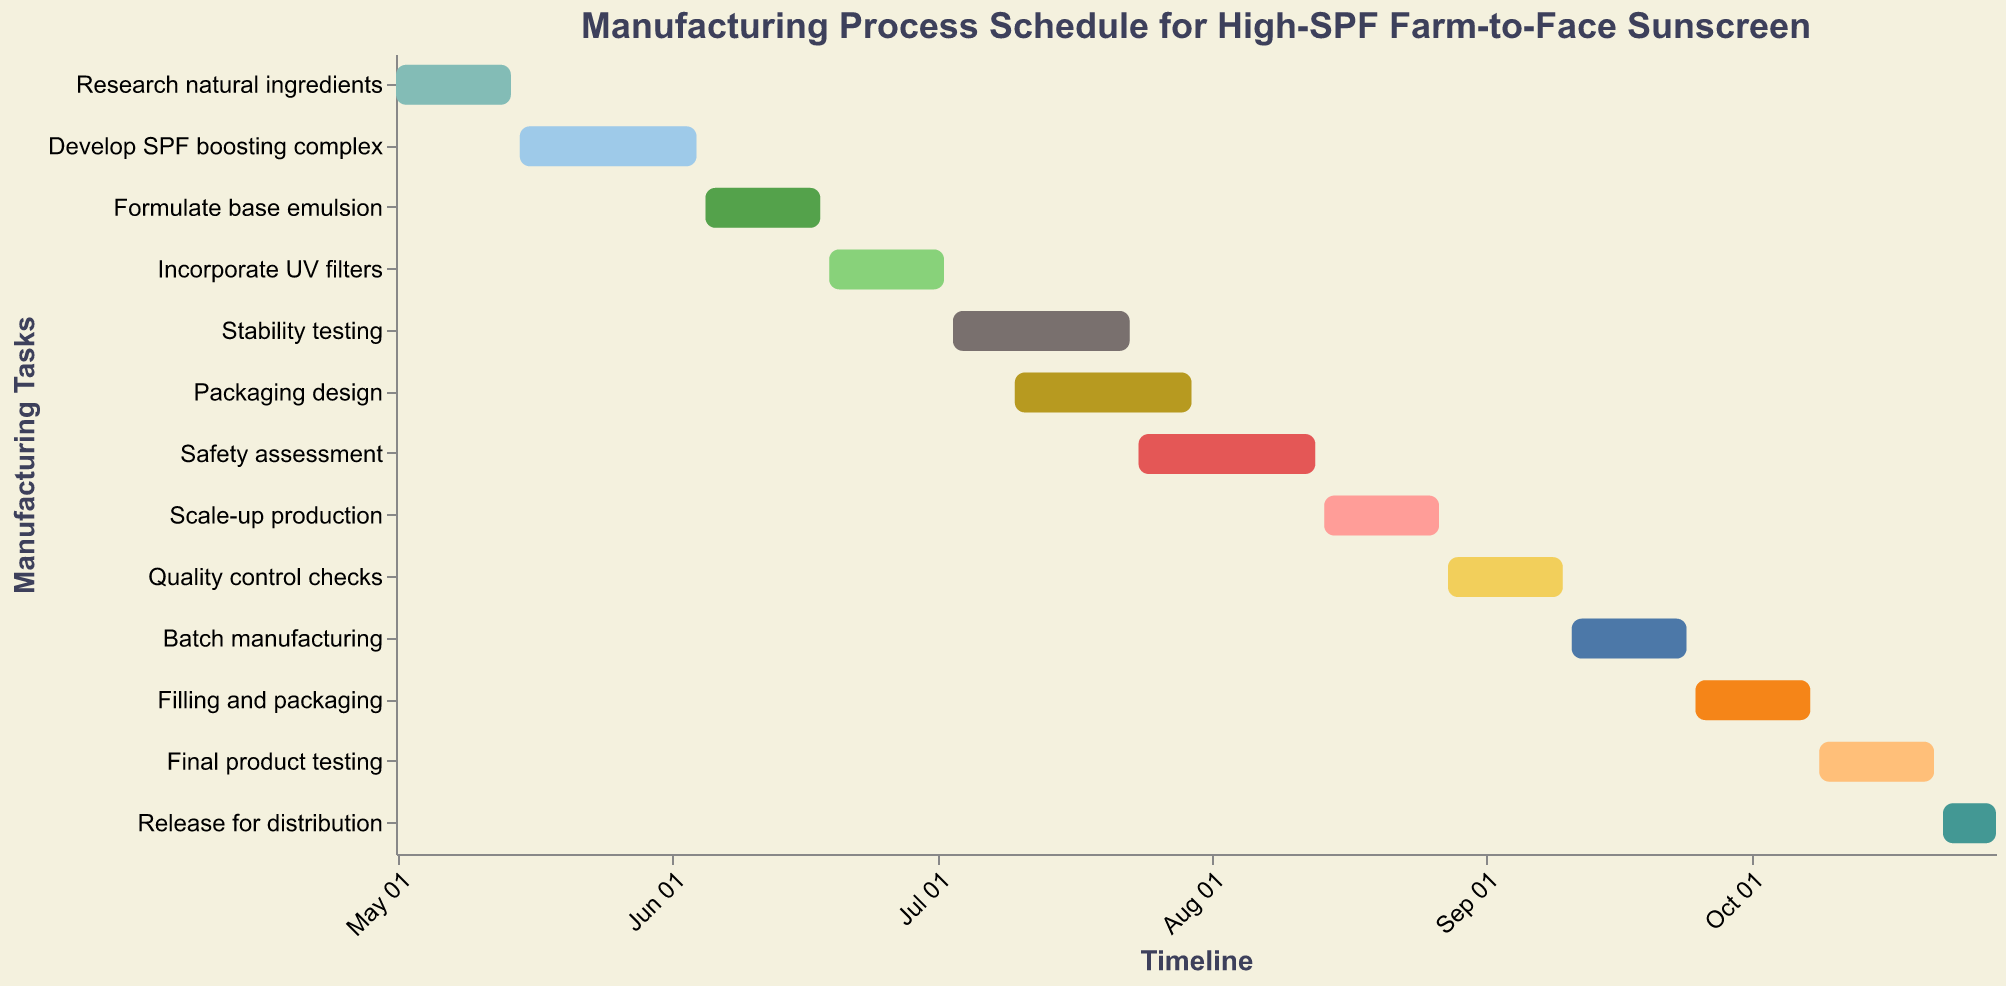What is the title of the figure? The title is located at the top of the Gantt Chart. It is "Manufacturing Process Schedule for High-SPF Farm-to-Face Sunscreen".
Answer: Manufacturing Process Schedule for High-SPF Farm-to-Face Sunscreen How many tasks are shown in the chart? Count the number of bars/tasks listed along the y-axis. There are 13 tasks in total.
Answer: 13 Which task starts first and on what date? The task that starts first can be identified by looking for the bar that begins at the earliest date on the x-axis. "Research natural ingredients" starts on May 1, 2023.
Answer: Research natural ingredients, May 1, 2023 When does the "Scale-up production" task begin and end? Locate the "Scale-up production" task along the y-axis and refer to the corresponding start and end dates along the x-axis. It starts on August 14, 2023, and ends on August 27, 2023.
Answer: August 14, 2023, to August 27, 2023 Which tasks are overlapping with "Stability testing"? Find "Stability testing" on the y-axis and note its duration. Then, check other tasks that span across the same timeframe. "Packaging design" overlaps with "Stability testing" from July 10, 2023, to July 23, 2023.
Answer: Packaging design What is the duration of the "Final product testing" task? To calculate the duration, subtract the start date from the end date. "Final product testing" runs from October 9, 2023, to October 22, 2023, which is 14 days.
Answer: 14 days Which task follows immediately after "Quality control checks"? Look at the end date of "Quality control checks" and identify the next task that starts immediately after this date along the timeline. "Batch manufacturing" starts immediately after, on September 11, 2023.
Answer: Batch manufacturing How long is the "Develop SPF boosting complex" task? Calculate the number of days between the start date (May 15, 2023) and the end date (June 4, 2023). It spans 21 days.
Answer: 21 days What is the last task before "Release for distribution"? Look at tasks close to the "Release for distribution" task, observe the end date of the preceding task. "Final product testing" is the last task before, ending on October 22, 2023.
Answer: Final product testing What is the total duration of the entire manufacturing process from the first task to the last task? Identify the start date of the first task ("Research natural ingredients" on May 1, 2023) and the end date of the last task ("Release for distribution" on October 29, 2023). Calculate the total number of days between these dates. The total duration is 182 days.
Answer: 182 days 